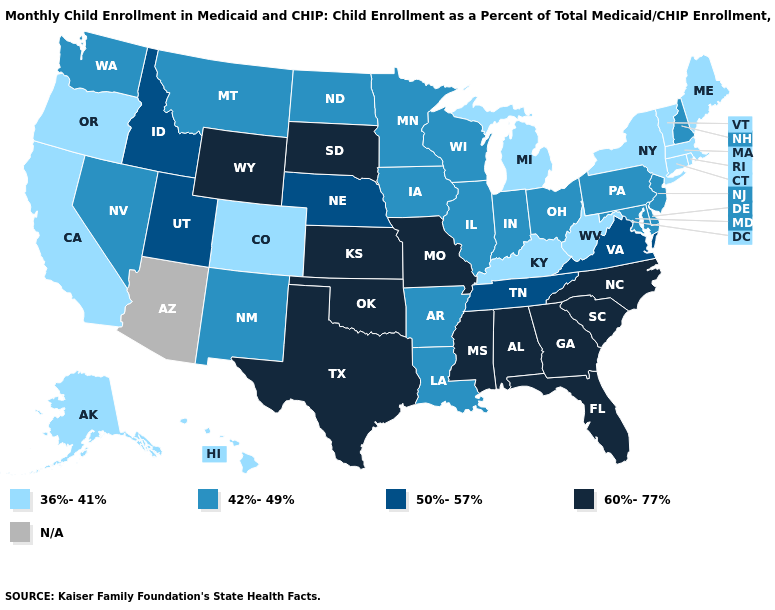Name the states that have a value in the range 60%-77%?
Answer briefly. Alabama, Florida, Georgia, Kansas, Mississippi, Missouri, North Carolina, Oklahoma, South Carolina, South Dakota, Texas, Wyoming. Name the states that have a value in the range 36%-41%?
Short answer required. Alaska, California, Colorado, Connecticut, Hawaii, Kentucky, Maine, Massachusetts, Michigan, New York, Oregon, Rhode Island, Vermont, West Virginia. What is the value of Hawaii?
Keep it brief. 36%-41%. Among the states that border Oklahoma , does Arkansas have the highest value?
Give a very brief answer. No. Which states have the lowest value in the USA?
Give a very brief answer. Alaska, California, Colorado, Connecticut, Hawaii, Kentucky, Maine, Massachusetts, Michigan, New York, Oregon, Rhode Island, Vermont, West Virginia. What is the highest value in the MidWest ?
Concise answer only. 60%-77%. Which states hav the highest value in the Northeast?
Give a very brief answer. New Hampshire, New Jersey, Pennsylvania. Name the states that have a value in the range 42%-49%?
Short answer required. Arkansas, Delaware, Illinois, Indiana, Iowa, Louisiana, Maryland, Minnesota, Montana, Nevada, New Hampshire, New Jersey, New Mexico, North Dakota, Ohio, Pennsylvania, Washington, Wisconsin. What is the value of Arizona?
Quick response, please. N/A. Name the states that have a value in the range N/A?
Short answer required. Arizona. Name the states that have a value in the range 50%-57%?
Write a very short answer. Idaho, Nebraska, Tennessee, Utah, Virginia. Does the first symbol in the legend represent the smallest category?
Keep it brief. Yes. What is the value of Vermont?
Concise answer only. 36%-41%. Name the states that have a value in the range 50%-57%?
Answer briefly. Idaho, Nebraska, Tennessee, Utah, Virginia. 